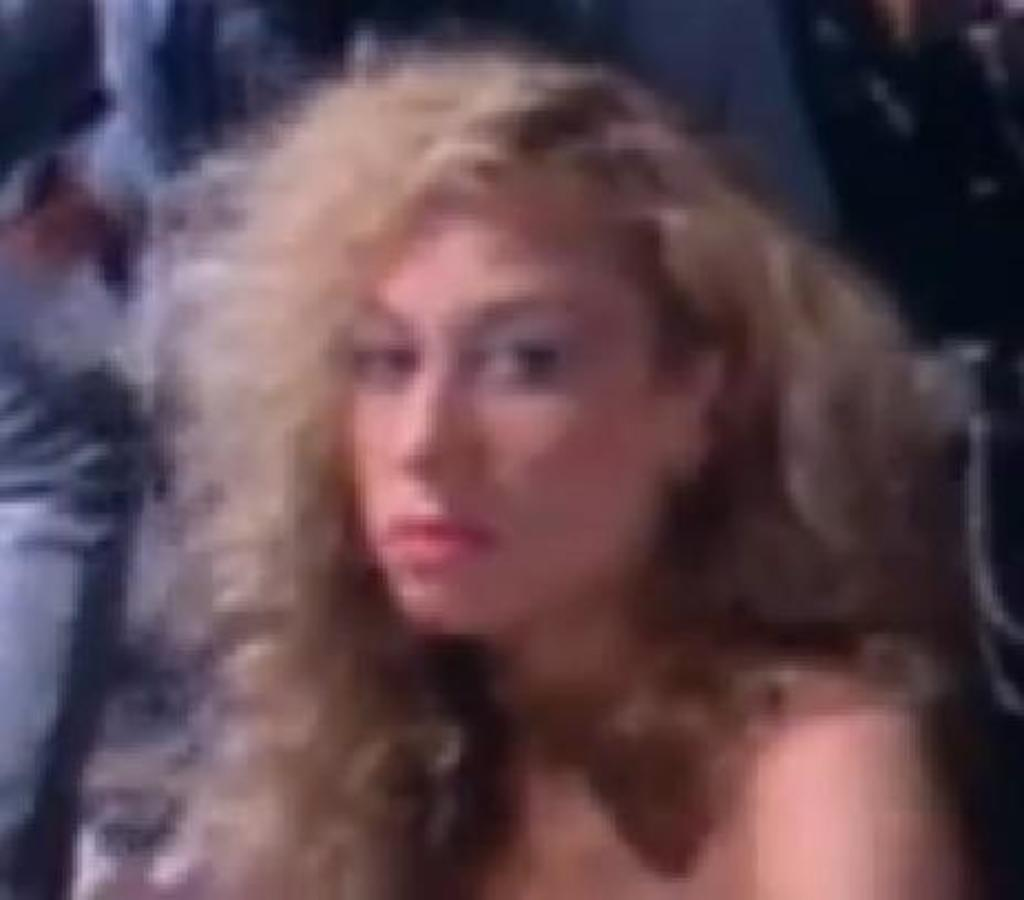What is the main subject of the picture? The main subject of the picture is a blurred image of a woman. Can you describe the woman's position in the image? The woman is sitting in front in the image. What is the woman doing in the picture? The woman is looking into the camera. How many cats can be seen playing with a snail in the image? There are no cats or snails present in the image; it features a blurred image of a woman sitting and looking into the camera. What type of coat is the woman wearing in the image? The image is blurred, and it is not possible to determine the type of coat the woman might be wearing. 